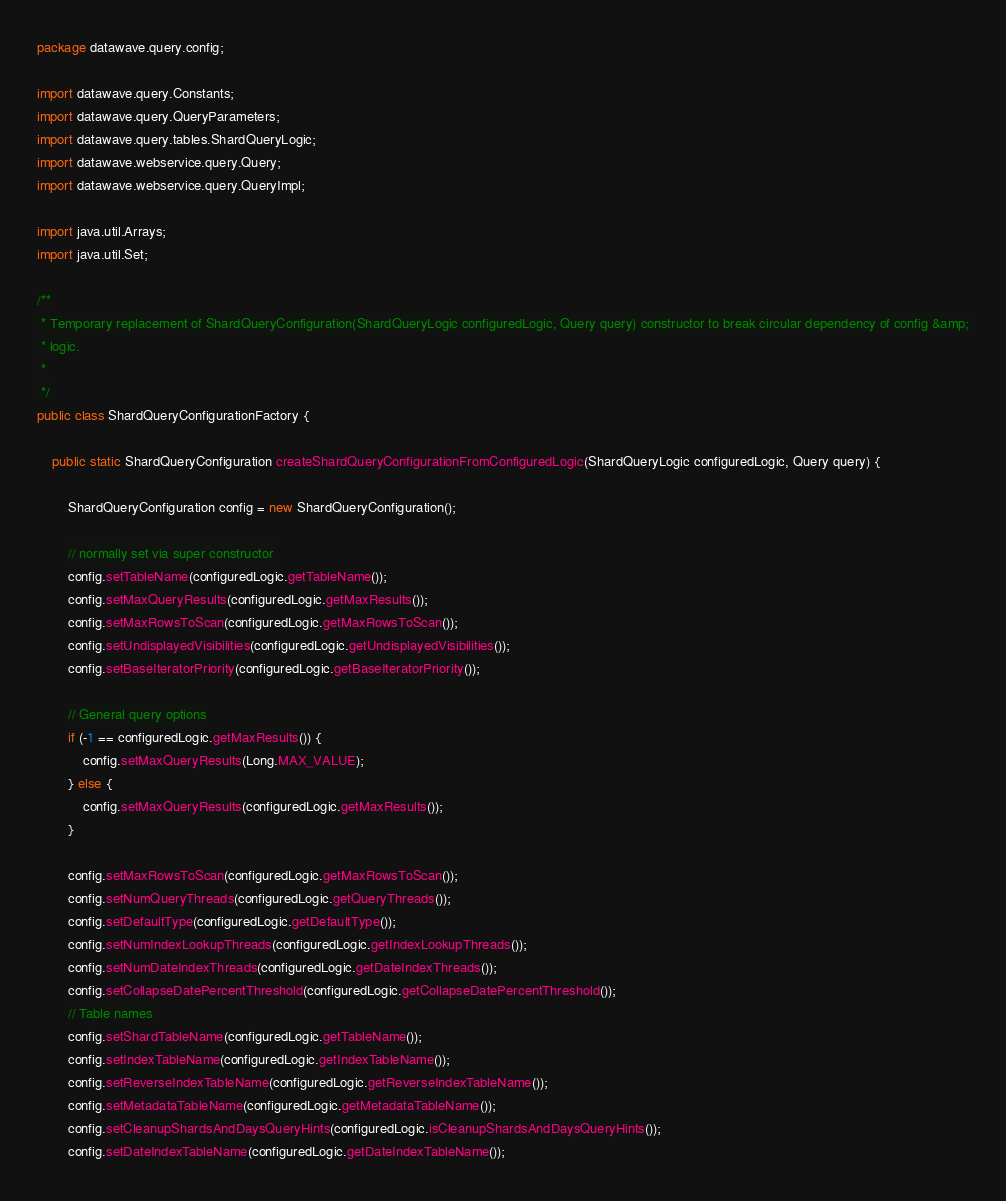<code> <loc_0><loc_0><loc_500><loc_500><_Java_>package datawave.query.config;

import datawave.query.Constants;
import datawave.query.QueryParameters;
import datawave.query.tables.ShardQueryLogic;
import datawave.webservice.query.Query;
import datawave.webservice.query.QueryImpl;

import java.util.Arrays;
import java.util.Set;

/**
 * Temporary replacement of ShardQueryConfiguration(ShardQueryLogic configuredLogic, Query query) constructor to break circular dependency of config &amp;
 * logic.
 *
 */
public class ShardQueryConfigurationFactory {
    
    public static ShardQueryConfiguration createShardQueryConfigurationFromConfiguredLogic(ShardQueryLogic configuredLogic, Query query) {
        
        ShardQueryConfiguration config = new ShardQueryConfiguration();
        
        // normally set via super constructor
        config.setTableName(configuredLogic.getTableName());
        config.setMaxQueryResults(configuredLogic.getMaxResults());
        config.setMaxRowsToScan(configuredLogic.getMaxRowsToScan());
        config.setUndisplayedVisibilities(configuredLogic.getUndisplayedVisibilities());
        config.setBaseIteratorPriority(configuredLogic.getBaseIteratorPriority());
        
        // General query options
        if (-1 == configuredLogic.getMaxResults()) {
            config.setMaxQueryResults(Long.MAX_VALUE);
        } else {
            config.setMaxQueryResults(configuredLogic.getMaxResults());
        }
        
        config.setMaxRowsToScan(configuredLogic.getMaxRowsToScan());
        config.setNumQueryThreads(configuredLogic.getQueryThreads());
        config.setDefaultType(configuredLogic.getDefaultType());
        config.setNumIndexLookupThreads(configuredLogic.getIndexLookupThreads());
        config.setNumDateIndexThreads(configuredLogic.getDateIndexThreads());
        config.setCollapseDatePercentThreshold(configuredLogic.getCollapseDatePercentThreshold());
        // Table names
        config.setShardTableName(configuredLogic.getTableName());
        config.setIndexTableName(configuredLogic.getIndexTableName());
        config.setReverseIndexTableName(configuredLogic.getReverseIndexTableName());
        config.setMetadataTableName(configuredLogic.getMetadataTableName());
        config.setCleanupShardsAndDaysQueryHints(configuredLogic.isCleanupShardsAndDaysQueryHints());
        config.setDateIndexTableName(configuredLogic.getDateIndexTableName());</code> 